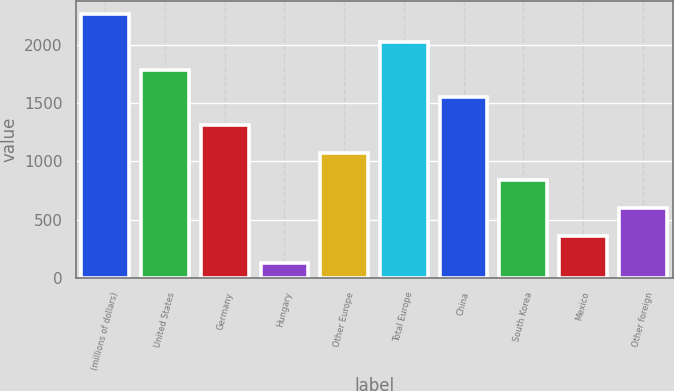<chart> <loc_0><loc_0><loc_500><loc_500><bar_chart><fcel>(millions of dollars)<fcel>United States<fcel>Germany<fcel>Hungary<fcel>Other Europe<fcel>Total Europe<fcel>China<fcel>South Korea<fcel>Mexico<fcel>Other foreign<nl><fcel>2263.84<fcel>1787.92<fcel>1312<fcel>122.2<fcel>1074.04<fcel>2025.88<fcel>1549.96<fcel>836.08<fcel>360.16<fcel>598.12<nl></chart> 